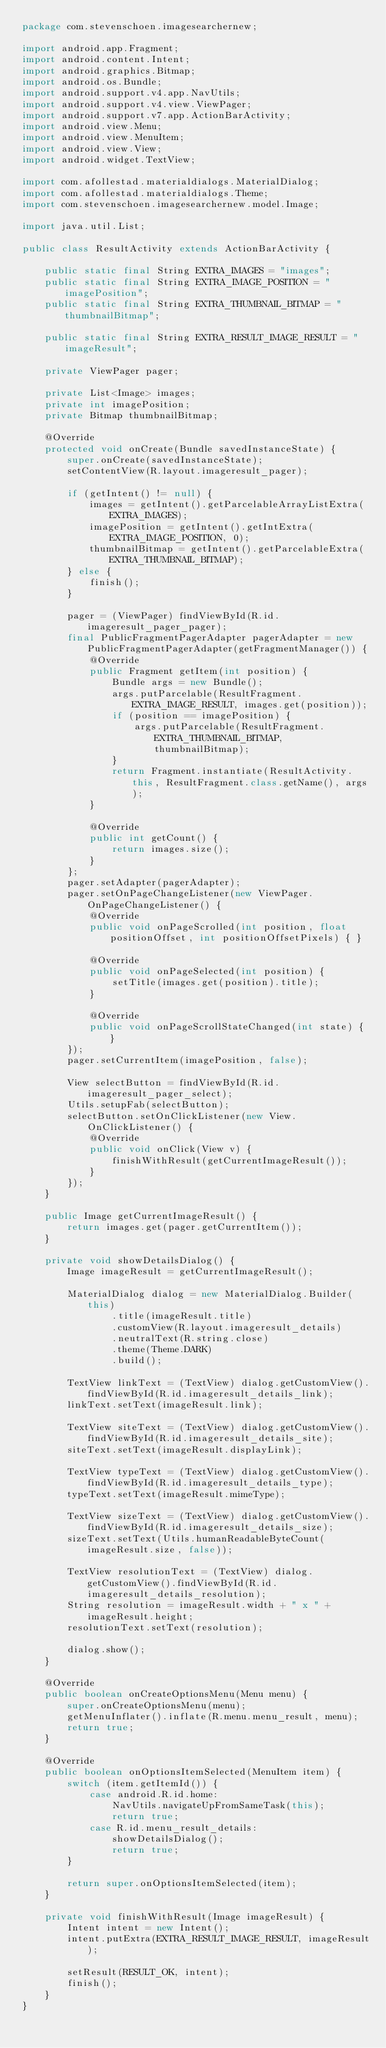Convert code to text. <code><loc_0><loc_0><loc_500><loc_500><_Java_>package com.stevenschoen.imagesearchernew;

import android.app.Fragment;
import android.content.Intent;
import android.graphics.Bitmap;
import android.os.Bundle;
import android.support.v4.app.NavUtils;
import android.support.v4.view.ViewPager;
import android.support.v7.app.ActionBarActivity;
import android.view.Menu;
import android.view.MenuItem;
import android.view.View;
import android.widget.TextView;

import com.afollestad.materialdialogs.MaterialDialog;
import com.afollestad.materialdialogs.Theme;
import com.stevenschoen.imagesearchernew.model.Image;

import java.util.List;

public class ResultActivity extends ActionBarActivity {

    public static final String EXTRA_IMAGES = "images";
    public static final String EXTRA_IMAGE_POSITION = "imagePosition";
    public static final String EXTRA_THUMBNAIL_BITMAP = "thumbnailBitmap";

    public static final String EXTRA_RESULT_IMAGE_RESULT = "imageResult";

    private ViewPager pager;

    private List<Image> images;
    private int imagePosition;
    private Bitmap thumbnailBitmap;

    @Override
    protected void onCreate(Bundle savedInstanceState) {
        super.onCreate(savedInstanceState);
        setContentView(R.layout.imageresult_pager);

        if (getIntent() != null) {
            images = getIntent().getParcelableArrayListExtra(EXTRA_IMAGES);
            imagePosition = getIntent().getIntExtra(EXTRA_IMAGE_POSITION, 0);
            thumbnailBitmap = getIntent().getParcelableExtra(EXTRA_THUMBNAIL_BITMAP);
        } else {
            finish();
        }

        pager = (ViewPager) findViewById(R.id.imageresult_pager_pager);
        final PublicFragmentPagerAdapter pagerAdapter = new PublicFragmentPagerAdapter(getFragmentManager()) {
            @Override
            public Fragment getItem(int position) {
                Bundle args = new Bundle();
                args.putParcelable(ResultFragment.EXTRA_IMAGE_RESULT, images.get(position));
                if (position == imagePosition) {
                    args.putParcelable(ResultFragment.EXTRA_THUMBNAIL_BITMAP, thumbnailBitmap);
                }
                return Fragment.instantiate(ResultActivity.this, ResultFragment.class.getName(), args);
            }

            @Override
            public int getCount() {
                return images.size();
            }
        };
        pager.setAdapter(pagerAdapter);
        pager.setOnPageChangeListener(new ViewPager.OnPageChangeListener() {
            @Override
            public void onPageScrolled(int position, float positionOffset, int positionOffsetPixels) { }

            @Override
            public void onPageSelected(int position) {
                setTitle(images.get(position).title);
            }

            @Override
            public void onPageScrollStateChanged(int state) { }
        });
        pager.setCurrentItem(imagePosition, false);

        View selectButton = findViewById(R.id.imageresult_pager_select);
        Utils.setupFab(selectButton);
        selectButton.setOnClickListener(new View.OnClickListener() {
            @Override
            public void onClick(View v) {
                finishWithResult(getCurrentImageResult());
            }
        });
    }

    public Image getCurrentImageResult() {
        return images.get(pager.getCurrentItem());
    }

    private void showDetailsDialog() {
        Image imageResult = getCurrentImageResult();

        MaterialDialog dialog = new MaterialDialog.Builder(this)
                .title(imageResult.title)
                .customView(R.layout.imageresult_details)
                .neutralText(R.string.close)
                .theme(Theme.DARK)
                .build();

        TextView linkText = (TextView) dialog.getCustomView().findViewById(R.id.imageresult_details_link);
        linkText.setText(imageResult.link);

        TextView siteText = (TextView) dialog.getCustomView().findViewById(R.id.imageresult_details_site);
        siteText.setText(imageResult.displayLink);

        TextView typeText = (TextView) dialog.getCustomView().findViewById(R.id.imageresult_details_type);
        typeText.setText(imageResult.mimeType);

        TextView sizeText = (TextView) dialog.getCustomView().findViewById(R.id.imageresult_details_size);
        sizeText.setText(Utils.humanReadableByteCount(imageResult.size, false));

        TextView resolutionText = (TextView) dialog.getCustomView().findViewById(R.id.imageresult_details_resolution);
        String resolution = imageResult.width + " x " + imageResult.height;
        resolutionText.setText(resolution);

        dialog.show();
    }

    @Override
    public boolean onCreateOptionsMenu(Menu menu) {
        super.onCreateOptionsMenu(menu);
        getMenuInflater().inflate(R.menu.menu_result, menu);
        return true;
    }

    @Override
    public boolean onOptionsItemSelected(MenuItem item) {
        switch (item.getItemId()) {
            case android.R.id.home:
                NavUtils.navigateUpFromSameTask(this);
                return true;
            case R.id.menu_result_details:
                showDetailsDialog();
                return true;
        }

        return super.onOptionsItemSelected(item);
    }

    private void finishWithResult(Image imageResult) {
        Intent intent = new Intent();
        intent.putExtra(EXTRA_RESULT_IMAGE_RESULT, imageResult);

        setResult(RESULT_OK, intent);
        finish();
    }
}
</code> 